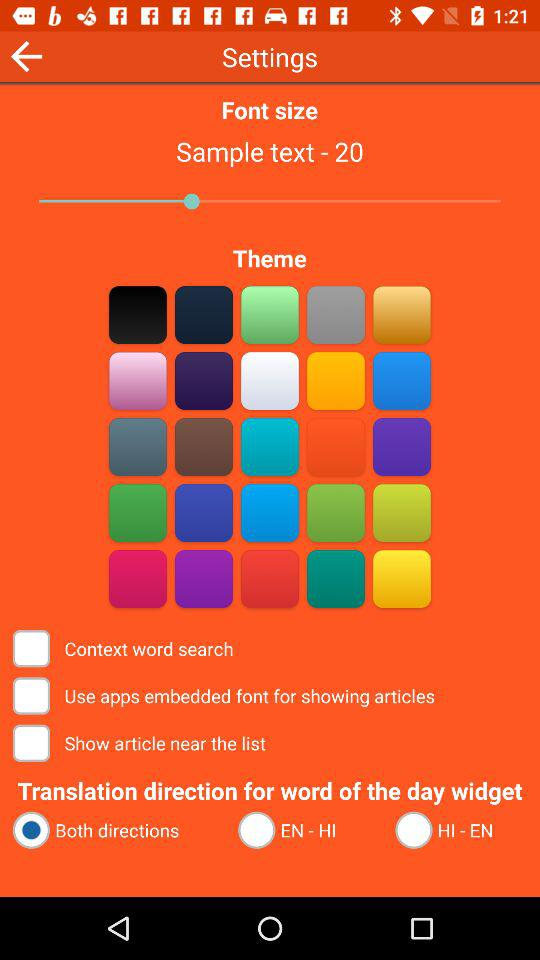What is the selected option for "Translation direction for word of the day widget"? The selected option is "Both directions". 